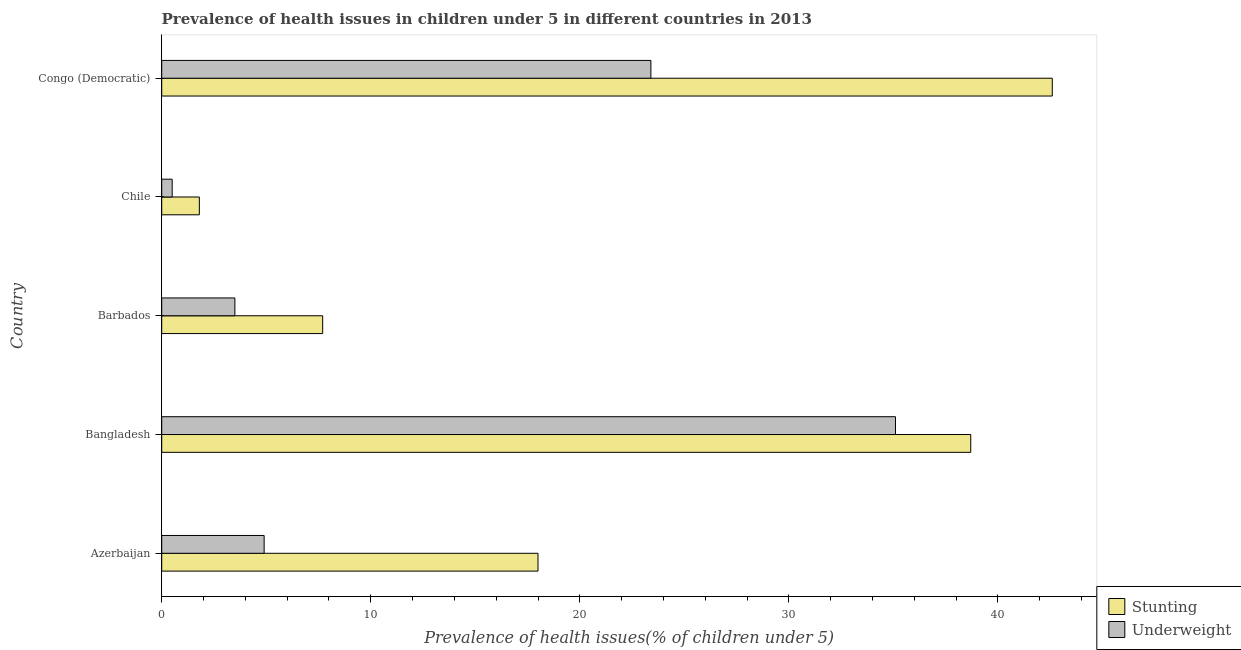How many groups of bars are there?
Your response must be concise. 5. Are the number of bars on each tick of the Y-axis equal?
Offer a terse response. Yes. What is the label of the 1st group of bars from the top?
Give a very brief answer. Congo (Democratic). In how many cases, is the number of bars for a given country not equal to the number of legend labels?
Your answer should be compact. 0. Across all countries, what is the maximum percentage of stunted children?
Provide a succinct answer. 42.6. In which country was the percentage of stunted children maximum?
Offer a terse response. Congo (Democratic). What is the total percentage of stunted children in the graph?
Provide a short and direct response. 108.8. What is the difference between the percentage of underweight children in Congo (Democratic) and the percentage of stunted children in Chile?
Ensure brevity in your answer.  21.6. What is the average percentage of underweight children per country?
Offer a terse response. 13.48. What is the difference between the percentage of stunted children and percentage of underweight children in Azerbaijan?
Offer a terse response. 13.1. In how many countries, is the percentage of stunted children greater than 12 %?
Your answer should be compact. 3. What is the ratio of the percentage of stunted children in Barbados to that in Chile?
Keep it short and to the point. 4.28. What is the difference between the highest and the second highest percentage of underweight children?
Your answer should be very brief. 11.7. What is the difference between the highest and the lowest percentage of stunted children?
Offer a very short reply. 40.8. In how many countries, is the percentage of stunted children greater than the average percentage of stunted children taken over all countries?
Make the answer very short. 2. Is the sum of the percentage of stunted children in Bangladesh and Barbados greater than the maximum percentage of underweight children across all countries?
Provide a succinct answer. Yes. What does the 2nd bar from the top in Azerbaijan represents?
Ensure brevity in your answer.  Stunting. What does the 1st bar from the bottom in Barbados represents?
Your answer should be compact. Stunting. Are all the bars in the graph horizontal?
Give a very brief answer. Yes. Are the values on the major ticks of X-axis written in scientific E-notation?
Give a very brief answer. No. Does the graph contain grids?
Provide a succinct answer. No. How many legend labels are there?
Provide a succinct answer. 2. How are the legend labels stacked?
Your answer should be compact. Vertical. What is the title of the graph?
Your answer should be compact. Prevalence of health issues in children under 5 in different countries in 2013. Does "Start a business" appear as one of the legend labels in the graph?
Offer a terse response. No. What is the label or title of the X-axis?
Your response must be concise. Prevalence of health issues(% of children under 5). What is the label or title of the Y-axis?
Your answer should be very brief. Country. What is the Prevalence of health issues(% of children under 5) of Underweight in Azerbaijan?
Keep it short and to the point. 4.9. What is the Prevalence of health issues(% of children under 5) of Stunting in Bangladesh?
Provide a succinct answer. 38.7. What is the Prevalence of health issues(% of children under 5) of Underweight in Bangladesh?
Offer a very short reply. 35.1. What is the Prevalence of health issues(% of children under 5) in Stunting in Barbados?
Provide a short and direct response. 7.7. What is the Prevalence of health issues(% of children under 5) in Underweight in Barbados?
Your answer should be very brief. 3.5. What is the Prevalence of health issues(% of children under 5) in Stunting in Chile?
Provide a short and direct response. 1.8. What is the Prevalence of health issues(% of children under 5) in Stunting in Congo (Democratic)?
Your answer should be compact. 42.6. What is the Prevalence of health issues(% of children under 5) of Underweight in Congo (Democratic)?
Keep it short and to the point. 23.4. Across all countries, what is the maximum Prevalence of health issues(% of children under 5) in Stunting?
Give a very brief answer. 42.6. Across all countries, what is the maximum Prevalence of health issues(% of children under 5) of Underweight?
Ensure brevity in your answer.  35.1. Across all countries, what is the minimum Prevalence of health issues(% of children under 5) in Stunting?
Offer a very short reply. 1.8. What is the total Prevalence of health issues(% of children under 5) in Stunting in the graph?
Ensure brevity in your answer.  108.8. What is the total Prevalence of health issues(% of children under 5) in Underweight in the graph?
Give a very brief answer. 67.4. What is the difference between the Prevalence of health issues(% of children under 5) in Stunting in Azerbaijan and that in Bangladesh?
Offer a very short reply. -20.7. What is the difference between the Prevalence of health issues(% of children under 5) in Underweight in Azerbaijan and that in Bangladesh?
Your answer should be very brief. -30.2. What is the difference between the Prevalence of health issues(% of children under 5) of Stunting in Azerbaijan and that in Congo (Democratic)?
Offer a terse response. -24.6. What is the difference between the Prevalence of health issues(% of children under 5) in Underweight in Azerbaijan and that in Congo (Democratic)?
Your response must be concise. -18.5. What is the difference between the Prevalence of health issues(% of children under 5) in Underweight in Bangladesh and that in Barbados?
Provide a succinct answer. 31.6. What is the difference between the Prevalence of health issues(% of children under 5) in Stunting in Bangladesh and that in Chile?
Keep it short and to the point. 36.9. What is the difference between the Prevalence of health issues(% of children under 5) in Underweight in Bangladesh and that in Chile?
Provide a succinct answer. 34.6. What is the difference between the Prevalence of health issues(% of children under 5) in Underweight in Bangladesh and that in Congo (Democratic)?
Ensure brevity in your answer.  11.7. What is the difference between the Prevalence of health issues(% of children under 5) of Underweight in Barbados and that in Chile?
Offer a very short reply. 3. What is the difference between the Prevalence of health issues(% of children under 5) in Stunting in Barbados and that in Congo (Democratic)?
Keep it short and to the point. -34.9. What is the difference between the Prevalence of health issues(% of children under 5) in Underweight in Barbados and that in Congo (Democratic)?
Offer a terse response. -19.9. What is the difference between the Prevalence of health issues(% of children under 5) in Stunting in Chile and that in Congo (Democratic)?
Your answer should be compact. -40.8. What is the difference between the Prevalence of health issues(% of children under 5) of Underweight in Chile and that in Congo (Democratic)?
Your answer should be very brief. -22.9. What is the difference between the Prevalence of health issues(% of children under 5) of Stunting in Azerbaijan and the Prevalence of health issues(% of children under 5) of Underweight in Bangladesh?
Make the answer very short. -17.1. What is the difference between the Prevalence of health issues(% of children under 5) in Stunting in Azerbaijan and the Prevalence of health issues(% of children under 5) in Underweight in Barbados?
Offer a terse response. 14.5. What is the difference between the Prevalence of health issues(% of children under 5) of Stunting in Azerbaijan and the Prevalence of health issues(% of children under 5) of Underweight in Chile?
Your answer should be very brief. 17.5. What is the difference between the Prevalence of health issues(% of children under 5) of Stunting in Azerbaijan and the Prevalence of health issues(% of children under 5) of Underweight in Congo (Democratic)?
Your answer should be compact. -5.4. What is the difference between the Prevalence of health issues(% of children under 5) in Stunting in Bangladesh and the Prevalence of health issues(% of children under 5) in Underweight in Barbados?
Provide a short and direct response. 35.2. What is the difference between the Prevalence of health issues(% of children under 5) in Stunting in Bangladesh and the Prevalence of health issues(% of children under 5) in Underweight in Chile?
Your answer should be very brief. 38.2. What is the difference between the Prevalence of health issues(% of children under 5) in Stunting in Barbados and the Prevalence of health issues(% of children under 5) in Underweight in Chile?
Give a very brief answer. 7.2. What is the difference between the Prevalence of health issues(% of children under 5) of Stunting in Barbados and the Prevalence of health issues(% of children under 5) of Underweight in Congo (Democratic)?
Provide a succinct answer. -15.7. What is the difference between the Prevalence of health issues(% of children under 5) of Stunting in Chile and the Prevalence of health issues(% of children under 5) of Underweight in Congo (Democratic)?
Provide a succinct answer. -21.6. What is the average Prevalence of health issues(% of children under 5) in Stunting per country?
Make the answer very short. 21.76. What is the average Prevalence of health issues(% of children under 5) in Underweight per country?
Your response must be concise. 13.48. What is the difference between the Prevalence of health issues(% of children under 5) in Stunting and Prevalence of health issues(% of children under 5) in Underweight in Bangladesh?
Make the answer very short. 3.6. What is the difference between the Prevalence of health issues(% of children under 5) in Stunting and Prevalence of health issues(% of children under 5) in Underweight in Chile?
Give a very brief answer. 1.3. What is the difference between the Prevalence of health issues(% of children under 5) of Stunting and Prevalence of health issues(% of children under 5) of Underweight in Congo (Democratic)?
Make the answer very short. 19.2. What is the ratio of the Prevalence of health issues(% of children under 5) in Stunting in Azerbaijan to that in Bangladesh?
Provide a short and direct response. 0.47. What is the ratio of the Prevalence of health issues(% of children under 5) of Underweight in Azerbaijan to that in Bangladesh?
Your response must be concise. 0.14. What is the ratio of the Prevalence of health issues(% of children under 5) of Stunting in Azerbaijan to that in Barbados?
Keep it short and to the point. 2.34. What is the ratio of the Prevalence of health issues(% of children under 5) of Underweight in Azerbaijan to that in Barbados?
Keep it short and to the point. 1.4. What is the ratio of the Prevalence of health issues(% of children under 5) of Underweight in Azerbaijan to that in Chile?
Your response must be concise. 9.8. What is the ratio of the Prevalence of health issues(% of children under 5) in Stunting in Azerbaijan to that in Congo (Democratic)?
Provide a succinct answer. 0.42. What is the ratio of the Prevalence of health issues(% of children under 5) in Underweight in Azerbaijan to that in Congo (Democratic)?
Offer a very short reply. 0.21. What is the ratio of the Prevalence of health issues(% of children under 5) in Stunting in Bangladesh to that in Barbados?
Your answer should be very brief. 5.03. What is the ratio of the Prevalence of health issues(% of children under 5) in Underweight in Bangladesh to that in Barbados?
Make the answer very short. 10.03. What is the ratio of the Prevalence of health issues(% of children under 5) in Stunting in Bangladesh to that in Chile?
Provide a succinct answer. 21.5. What is the ratio of the Prevalence of health issues(% of children under 5) of Underweight in Bangladesh to that in Chile?
Make the answer very short. 70.2. What is the ratio of the Prevalence of health issues(% of children under 5) of Stunting in Bangladesh to that in Congo (Democratic)?
Your response must be concise. 0.91. What is the ratio of the Prevalence of health issues(% of children under 5) in Underweight in Bangladesh to that in Congo (Democratic)?
Your answer should be very brief. 1.5. What is the ratio of the Prevalence of health issues(% of children under 5) of Stunting in Barbados to that in Chile?
Your response must be concise. 4.28. What is the ratio of the Prevalence of health issues(% of children under 5) in Stunting in Barbados to that in Congo (Democratic)?
Offer a very short reply. 0.18. What is the ratio of the Prevalence of health issues(% of children under 5) of Underweight in Barbados to that in Congo (Democratic)?
Your response must be concise. 0.15. What is the ratio of the Prevalence of health issues(% of children under 5) in Stunting in Chile to that in Congo (Democratic)?
Offer a very short reply. 0.04. What is the ratio of the Prevalence of health issues(% of children under 5) of Underweight in Chile to that in Congo (Democratic)?
Ensure brevity in your answer.  0.02. What is the difference between the highest and the lowest Prevalence of health issues(% of children under 5) in Stunting?
Provide a succinct answer. 40.8. What is the difference between the highest and the lowest Prevalence of health issues(% of children under 5) of Underweight?
Keep it short and to the point. 34.6. 